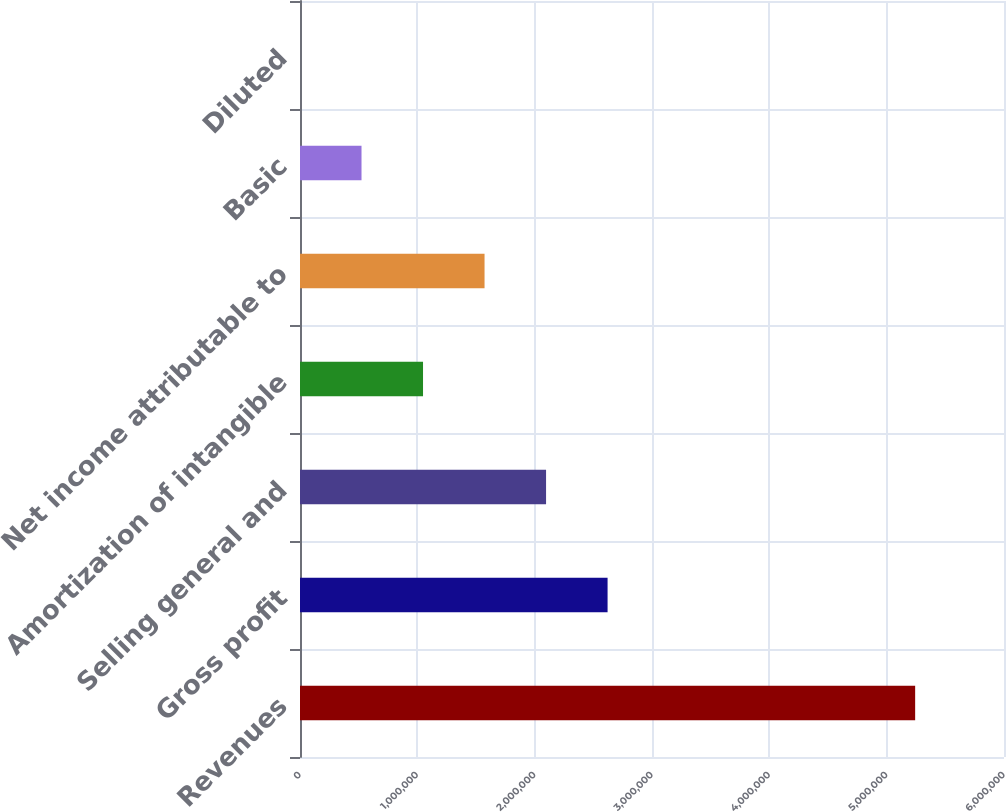<chart> <loc_0><loc_0><loc_500><loc_500><bar_chart><fcel>Revenues<fcel>Gross profit<fcel>Selling general and<fcel>Amortization of intangible<fcel>Net income attributable to<fcel>Basic<fcel>Diluted<nl><fcel>5.24279e+06<fcel>2.6214e+06<fcel>2.09712e+06<fcel>1.04856e+06<fcel>1.57284e+06<fcel>524280<fcel>1.37<nl></chart> 